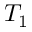Convert formula to latex. <formula><loc_0><loc_0><loc_500><loc_500>T _ { 1 }</formula> 